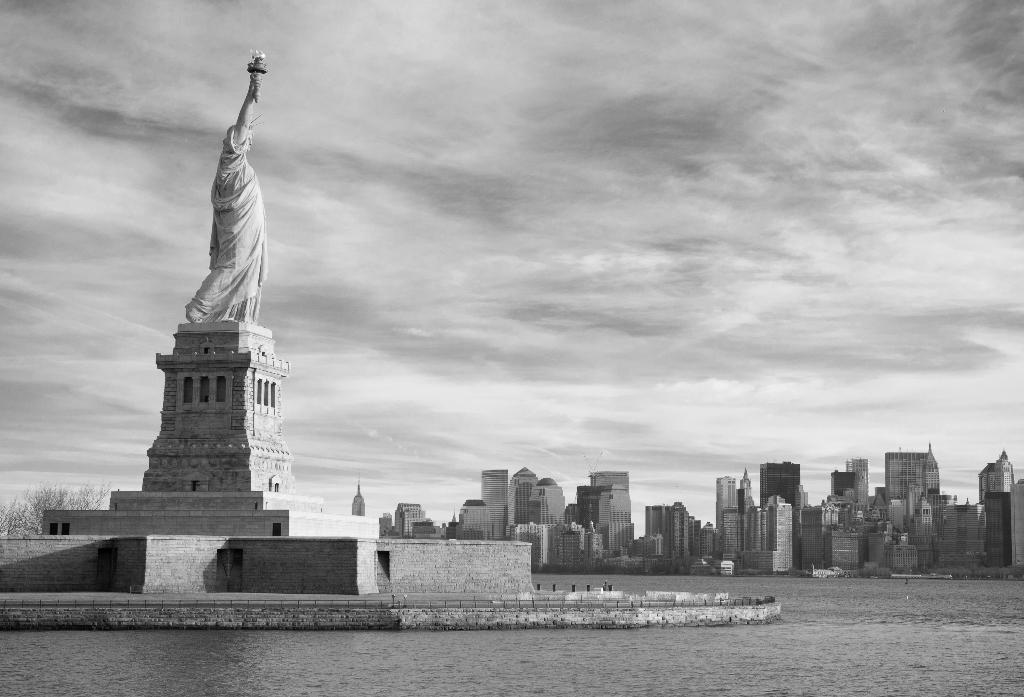Can you describe this image briefly? In this image there is the statue of liberty structure in the harbor, in the background of the image there are buildings and trees, at the top of the image there are clouds in the sky. 